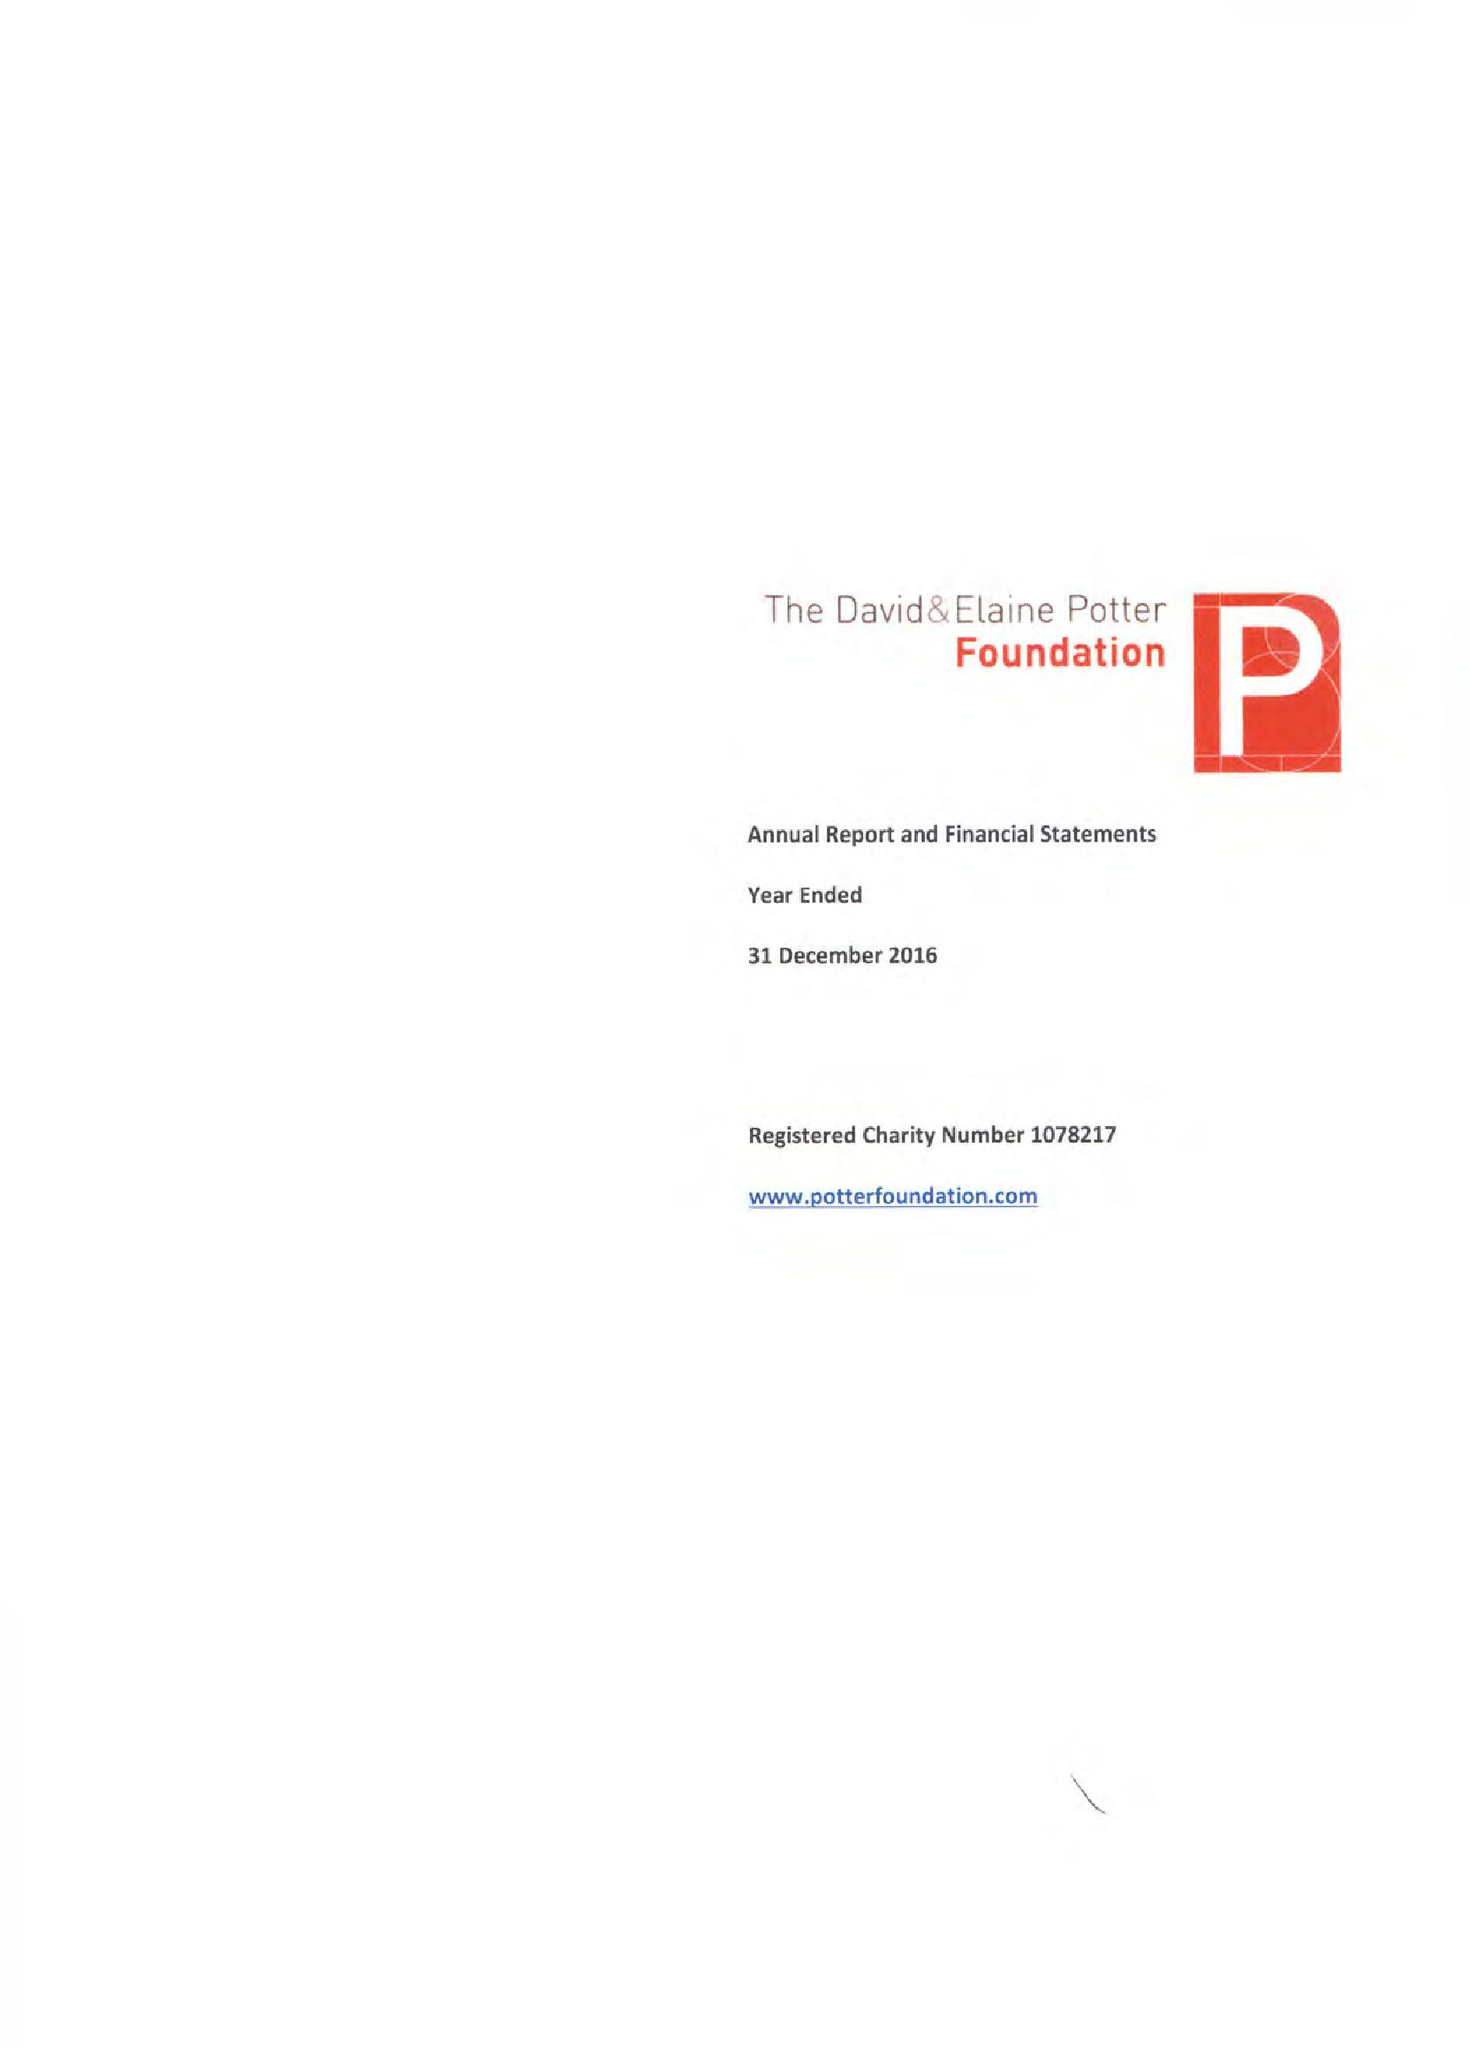What is the value for the report_date?
Answer the question using a single word or phrase. 2016-12-31 